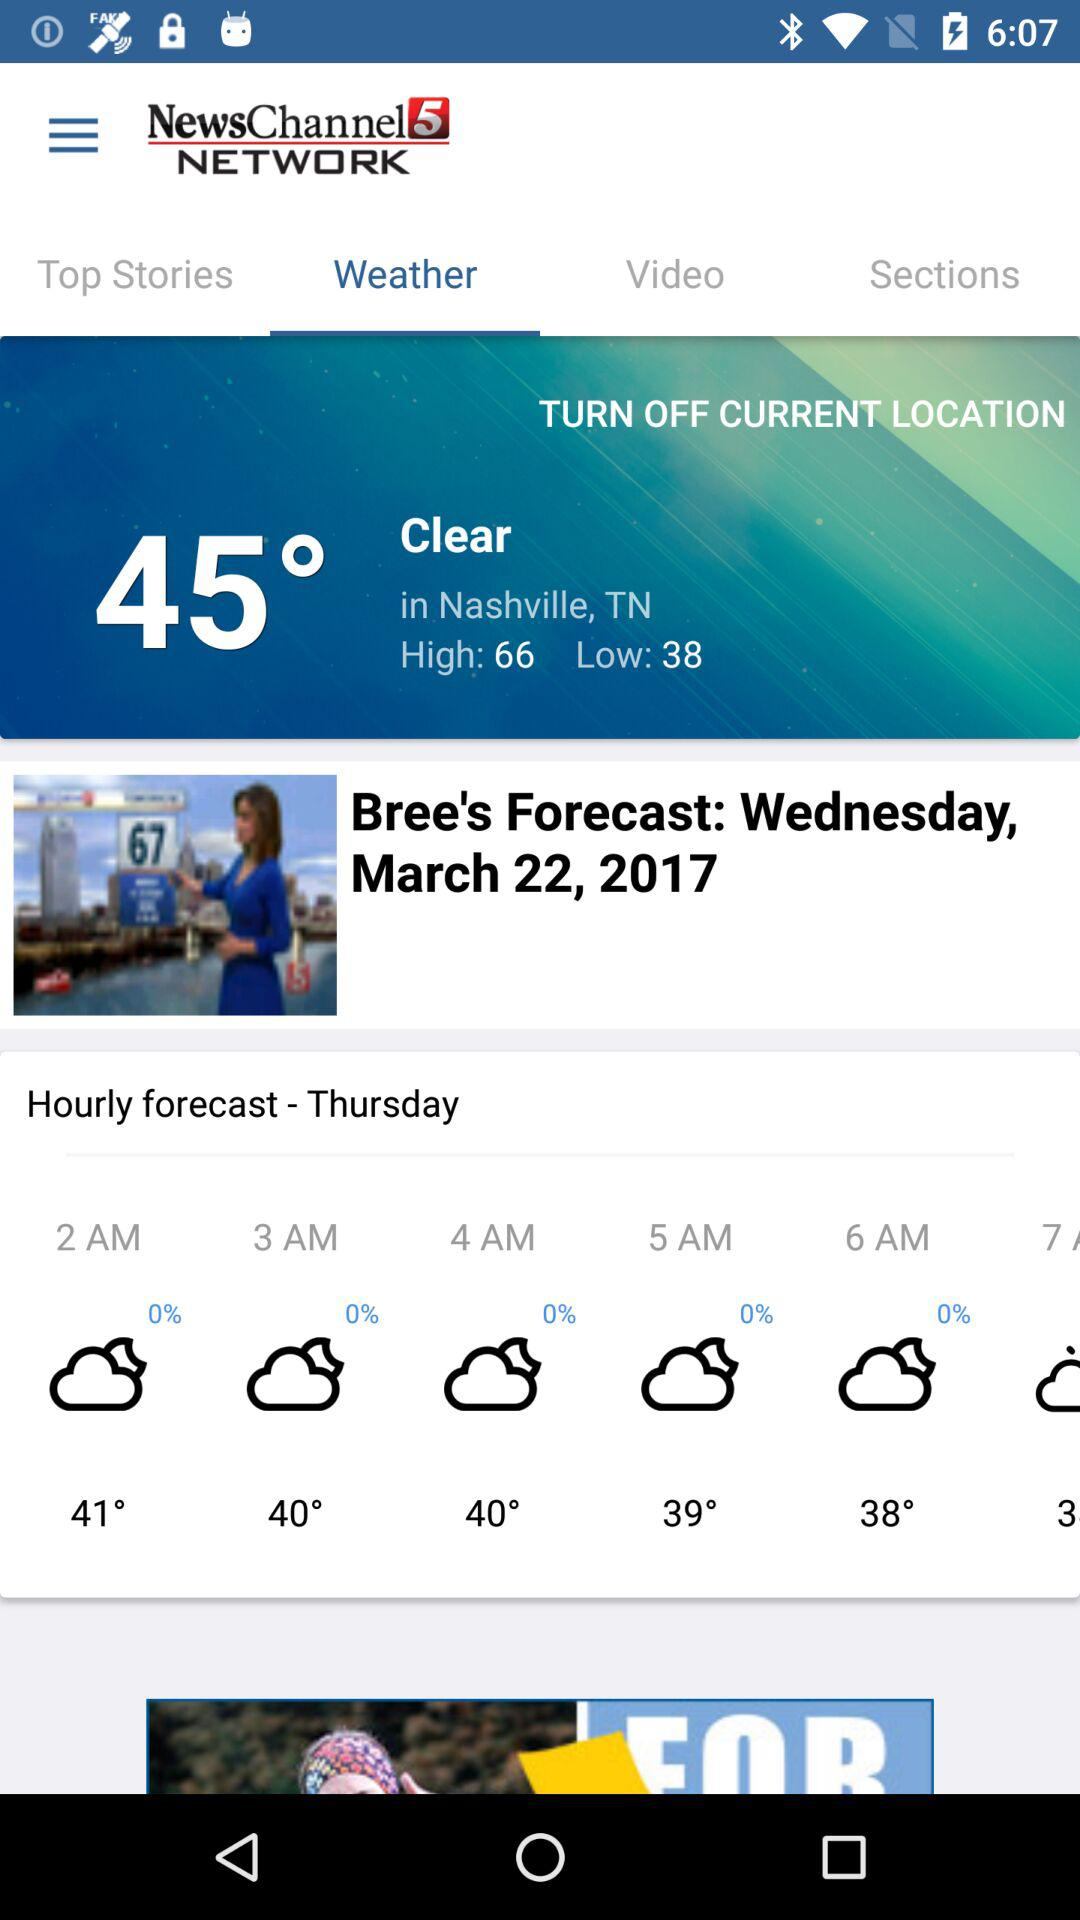What is the mentioned location? The mentioned locations are Nashville, TN and Bree. 